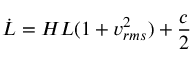Convert formula to latex. <formula><loc_0><loc_0><loc_500><loc_500>{ \dot { L } } = H L ( 1 + v _ { r m s } ^ { 2 } ) + { \frac { c } { 2 } }</formula> 